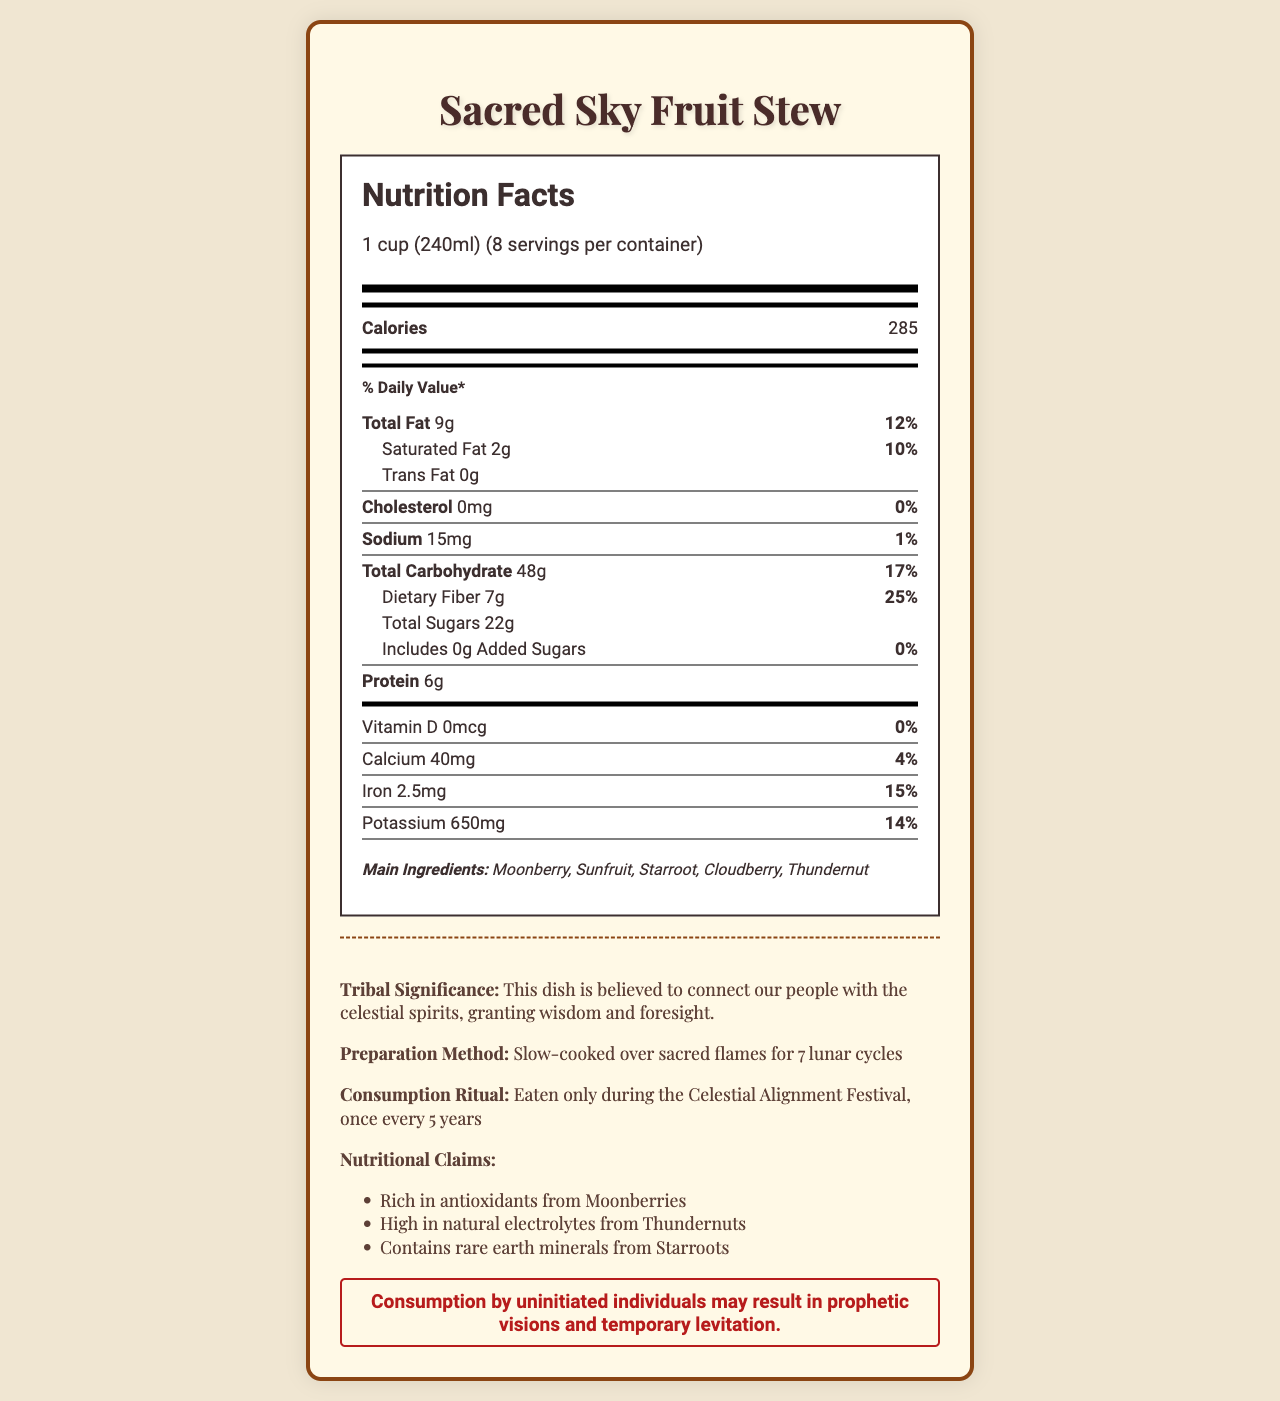what is the name of the dish? The name of the dish is clearly stated at the beginning of the document.
Answer: Sacred Sky Fruit Stew what is the serving size of the dish? The serving size is listed right below the nutrition facts title.
Answer: 1 cup (240ml) how many servings per container are there? The number of servings per container is noted under the serving size.
Answer: 8 how many calories are there per serving? The calorie content is listed immediately within the main nutrition facts panel.
Answer: 285 what are the main ingredients in the dish? The main ingredients are listed in the ingredients section at the bottom of the nutrition label.
Answer: Moonberry, Sunfruit, Starroot, Cloudberry, Thundernut how much total fat does one serving contain? The amount of total fat per serving is noted in the nutritional breakdown.
Answer: 9g what percentage daily value of dietary fiber does one serving provide? The daily value percentage of dietary fiber is provided next to the amount in grams.
Answer: 25% which component has the highest daily percentage value? A. Iron B. Dietary Fiber C. Total Carbohydrate D. Calcium Dietary Fiber has the highest daily percentage value at 25%.
Answer: B what is the daily value percentage of sodium per serving? A. 1% B. 5% C. 15% D. 10% Sodium per serving has a daily value of 1%.
Answer: A does the dish contain any added sugars? The document specifies that added sugars are 0g, with 0% of daily value.
Answer: No can consumption by uninitiated individuals result in any side effects? The warning statement mentions that consumption may result in prophetic visions and temporary levitation for uninitiated individuals.
Answer: Yes what is the tribal significance of the dish? This information is provided in the tribal significance section.
Answer: This dish is believed to connect our people with the celestial spirits, granting wisdom and foresight. describe the warning statement provided in the document This statement is found at the bottom of the document, under a distinct warning label.
Answer: Consumption by uninitiated individuals may result in prophetic visions and temporary levitation. what kind of minerals does the dish contain? The document mentions that Starroots contain rare earth minerals, but it does not specify which minerals.
Answer: Not enough information 